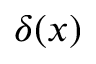Convert formula to latex. <formula><loc_0><loc_0><loc_500><loc_500>\delta ( x )</formula> 